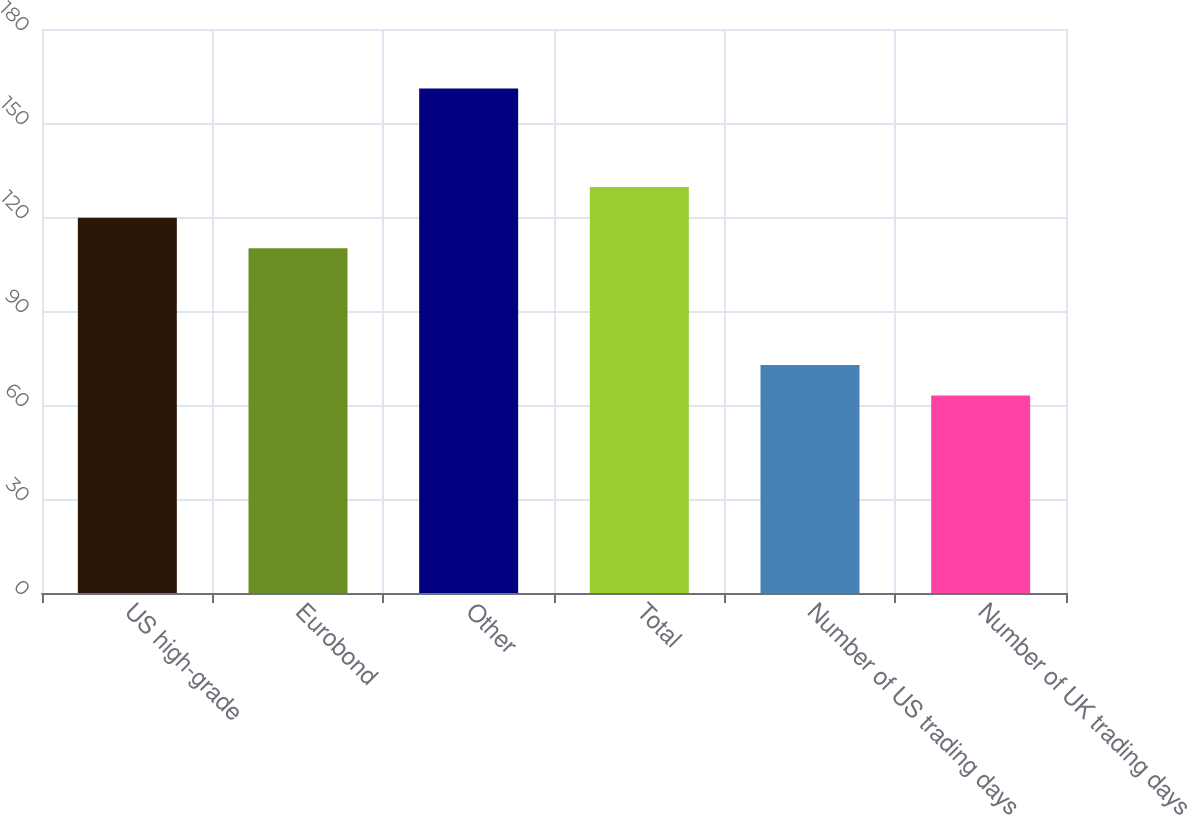<chart> <loc_0><loc_0><loc_500><loc_500><bar_chart><fcel>US high-grade<fcel>Eurobond<fcel>Other<fcel>Total<fcel>Number of US trading days<fcel>Number of UK trading days<nl><fcel>119.8<fcel>110<fcel>161<fcel>129.6<fcel>72.8<fcel>63<nl></chart> 